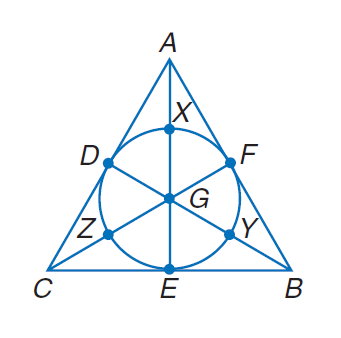Answer the mathemtical geometry problem and directly provide the correct option letter.
Question: Find the perimeter of the polygon for the given information. B Y = C Z = A X = 2.5 diameter of \odot G = 5.
Choices: A: 15 B: 20 C: 15 \sqrt { 3 } D: 30 C 